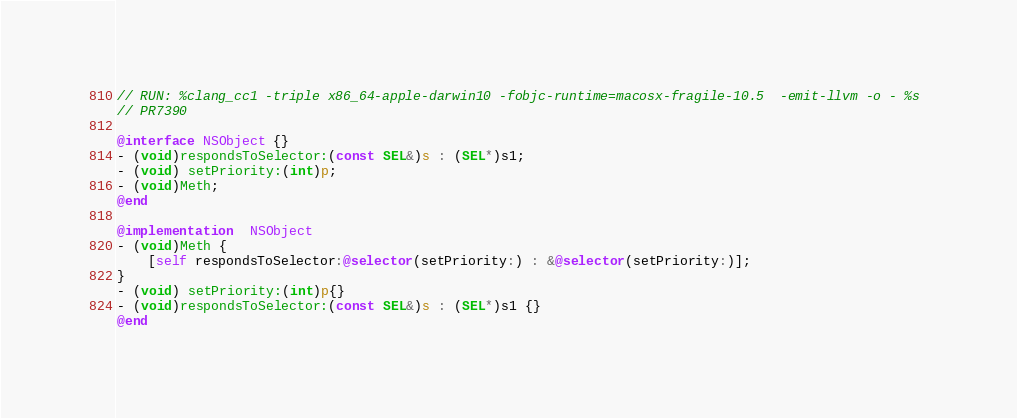<code> <loc_0><loc_0><loc_500><loc_500><_ObjectiveC_>// RUN: %clang_cc1 -triple x86_64-apple-darwin10 -fobjc-runtime=macosx-fragile-10.5  -emit-llvm -o - %s 
// PR7390

@interface NSObject {}
- (void)respondsToSelector:(const SEL&)s : (SEL*)s1;
- (void) setPriority:(int)p;
- (void)Meth;
@end

@implementation  NSObject
- (void)Meth {
    [self respondsToSelector:@selector(setPriority:) : &@selector(setPriority:)];
}
- (void) setPriority:(int)p{}
- (void)respondsToSelector:(const SEL&)s : (SEL*)s1 {}
@end
</code> 